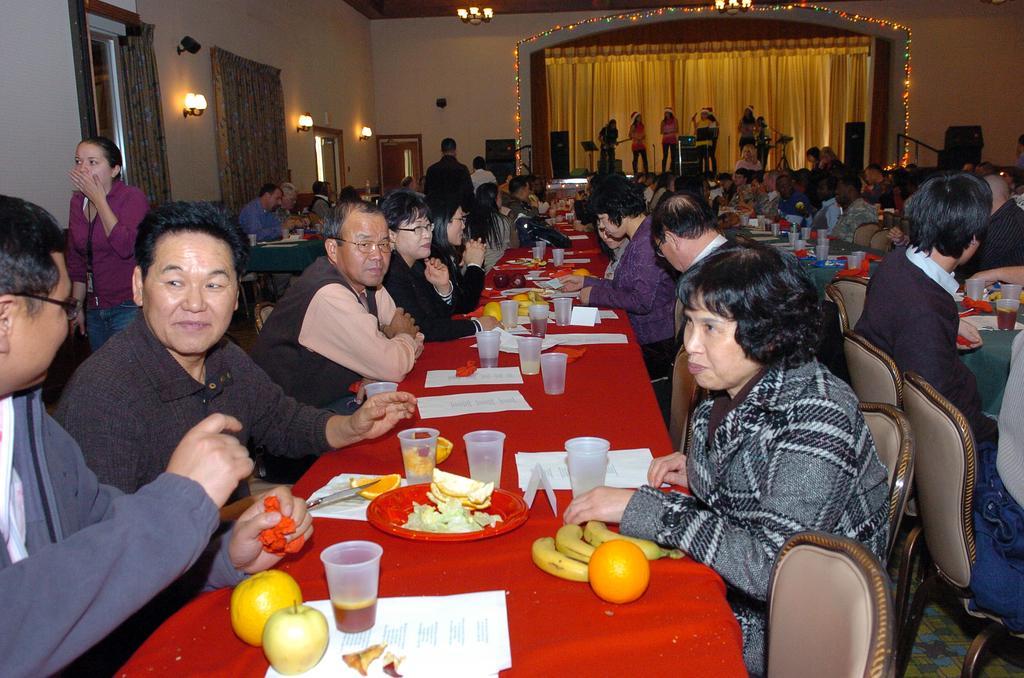How would you summarize this image in a sentence or two? This image is clicked in a room. There are lights on the top and there are some people in the middle on the stage, who are playing some musical instruments. There are tables and chairs. People are sitting on chairs or tables. On the tables there are fruits, glasses, papers, plate, tissues. There are windows on the left side and there are curtains too. 